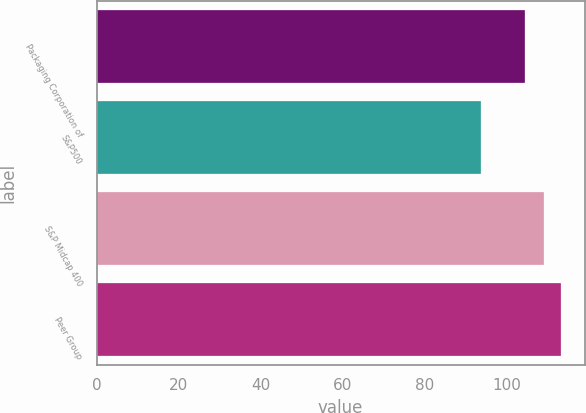<chart> <loc_0><loc_0><loc_500><loc_500><bar_chart><fcel>Packaging Corporation of<fcel>S&P500<fcel>S&P Midcap 400<fcel>Peer Group<nl><fcel>104.36<fcel>93.61<fcel>109.02<fcel>113.25<nl></chart> 